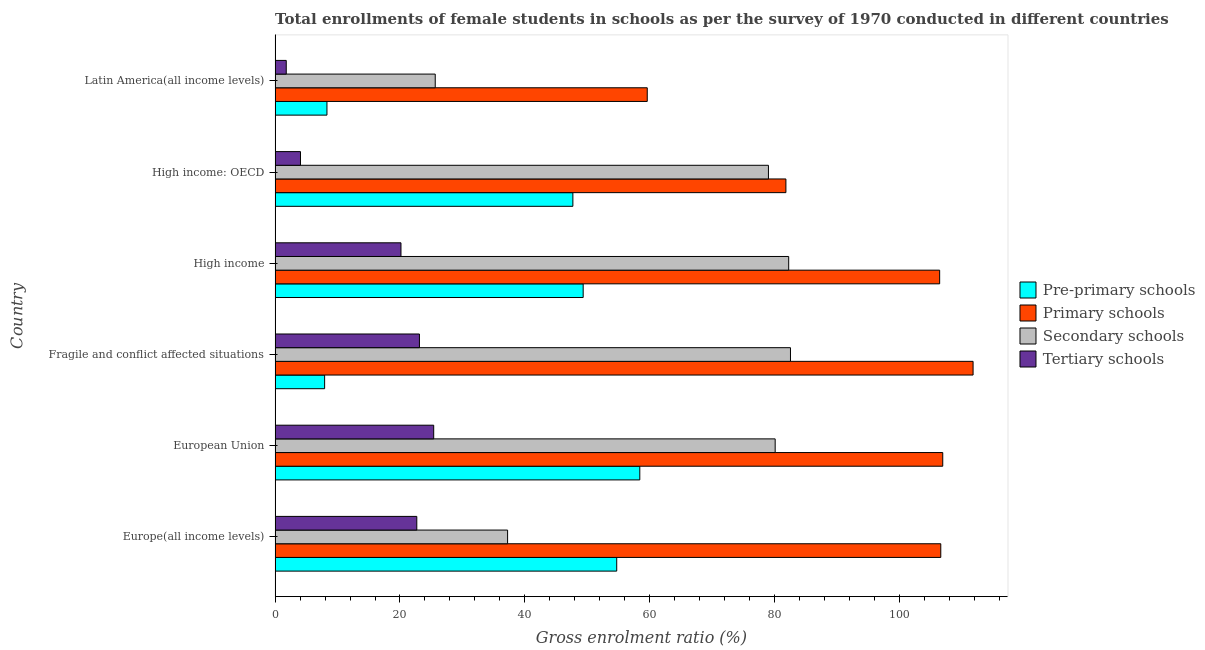How many different coloured bars are there?
Ensure brevity in your answer.  4. Are the number of bars on each tick of the Y-axis equal?
Give a very brief answer. Yes. How many bars are there on the 6th tick from the top?
Provide a short and direct response. 4. What is the label of the 6th group of bars from the top?
Provide a short and direct response. Europe(all income levels). What is the gross enrolment ratio(female) in pre-primary schools in Fragile and conflict affected situations?
Ensure brevity in your answer.  7.93. Across all countries, what is the maximum gross enrolment ratio(female) in pre-primary schools?
Provide a succinct answer. 58.41. Across all countries, what is the minimum gross enrolment ratio(female) in pre-primary schools?
Provide a short and direct response. 7.93. In which country was the gross enrolment ratio(female) in pre-primary schools maximum?
Your answer should be compact. European Union. In which country was the gross enrolment ratio(female) in secondary schools minimum?
Provide a succinct answer. Latin America(all income levels). What is the total gross enrolment ratio(female) in primary schools in the graph?
Your answer should be very brief. 573.13. What is the difference between the gross enrolment ratio(female) in pre-primary schools in European Union and that in High income?
Provide a short and direct response. 9.07. What is the difference between the gross enrolment ratio(female) in primary schools in Europe(all income levels) and the gross enrolment ratio(female) in pre-primary schools in European Union?
Give a very brief answer. 48.2. What is the average gross enrolment ratio(female) in pre-primary schools per country?
Ensure brevity in your answer.  37.73. What is the difference between the gross enrolment ratio(female) in secondary schools and gross enrolment ratio(female) in pre-primary schools in Latin America(all income levels)?
Keep it short and to the point. 17.34. What is the ratio of the gross enrolment ratio(female) in primary schools in European Union to that in Fragile and conflict affected situations?
Your answer should be compact. 0.96. What is the difference between the highest and the second highest gross enrolment ratio(female) in tertiary schools?
Provide a short and direct response. 2.29. What is the difference between the highest and the lowest gross enrolment ratio(female) in secondary schools?
Ensure brevity in your answer.  56.89. Is the sum of the gross enrolment ratio(female) in primary schools in Europe(all income levels) and Fragile and conflict affected situations greater than the maximum gross enrolment ratio(female) in pre-primary schools across all countries?
Give a very brief answer. Yes. What does the 4th bar from the top in European Union represents?
Offer a very short reply. Pre-primary schools. What does the 3rd bar from the bottom in High income represents?
Offer a very short reply. Secondary schools. Is it the case that in every country, the sum of the gross enrolment ratio(female) in pre-primary schools and gross enrolment ratio(female) in primary schools is greater than the gross enrolment ratio(female) in secondary schools?
Make the answer very short. Yes. How many bars are there?
Keep it short and to the point. 24. Are all the bars in the graph horizontal?
Offer a terse response. Yes. How many countries are there in the graph?
Keep it short and to the point. 6. Are the values on the major ticks of X-axis written in scientific E-notation?
Ensure brevity in your answer.  No. How many legend labels are there?
Keep it short and to the point. 4. What is the title of the graph?
Offer a very short reply. Total enrollments of female students in schools as per the survey of 1970 conducted in different countries. What is the Gross enrolment ratio (%) in Pre-primary schools in Europe(all income levels)?
Ensure brevity in your answer.  54.71. What is the Gross enrolment ratio (%) in Primary schools in Europe(all income levels)?
Your answer should be very brief. 106.6. What is the Gross enrolment ratio (%) of Secondary schools in Europe(all income levels)?
Provide a succinct answer. 37.23. What is the Gross enrolment ratio (%) in Tertiary schools in Europe(all income levels)?
Offer a very short reply. 22.69. What is the Gross enrolment ratio (%) in Pre-primary schools in European Union?
Your response must be concise. 58.41. What is the Gross enrolment ratio (%) of Primary schools in European Union?
Give a very brief answer. 106.92. What is the Gross enrolment ratio (%) of Secondary schools in European Union?
Offer a very short reply. 80.08. What is the Gross enrolment ratio (%) of Tertiary schools in European Union?
Your answer should be compact. 25.4. What is the Gross enrolment ratio (%) in Pre-primary schools in Fragile and conflict affected situations?
Provide a short and direct response. 7.93. What is the Gross enrolment ratio (%) of Primary schools in Fragile and conflict affected situations?
Provide a succinct answer. 111.78. What is the Gross enrolment ratio (%) of Secondary schools in Fragile and conflict affected situations?
Ensure brevity in your answer.  82.53. What is the Gross enrolment ratio (%) of Tertiary schools in Fragile and conflict affected situations?
Ensure brevity in your answer.  23.12. What is the Gross enrolment ratio (%) in Pre-primary schools in High income?
Make the answer very short. 49.34. What is the Gross enrolment ratio (%) of Primary schools in High income?
Your response must be concise. 106.42. What is the Gross enrolment ratio (%) of Secondary schools in High income?
Keep it short and to the point. 82.25. What is the Gross enrolment ratio (%) in Tertiary schools in High income?
Ensure brevity in your answer.  20.16. What is the Gross enrolment ratio (%) in Pre-primary schools in High income: OECD?
Make the answer very short. 47.69. What is the Gross enrolment ratio (%) in Primary schools in High income: OECD?
Make the answer very short. 81.8. What is the Gross enrolment ratio (%) of Secondary schools in High income: OECD?
Offer a terse response. 79.01. What is the Gross enrolment ratio (%) in Tertiary schools in High income: OECD?
Keep it short and to the point. 4.07. What is the Gross enrolment ratio (%) in Pre-primary schools in Latin America(all income levels)?
Make the answer very short. 8.31. What is the Gross enrolment ratio (%) in Primary schools in Latin America(all income levels)?
Offer a terse response. 59.6. What is the Gross enrolment ratio (%) of Secondary schools in Latin America(all income levels)?
Give a very brief answer. 25.65. What is the Gross enrolment ratio (%) in Tertiary schools in Latin America(all income levels)?
Make the answer very short. 1.79. Across all countries, what is the maximum Gross enrolment ratio (%) of Pre-primary schools?
Make the answer very short. 58.41. Across all countries, what is the maximum Gross enrolment ratio (%) of Primary schools?
Your response must be concise. 111.78. Across all countries, what is the maximum Gross enrolment ratio (%) of Secondary schools?
Offer a terse response. 82.53. Across all countries, what is the maximum Gross enrolment ratio (%) in Tertiary schools?
Give a very brief answer. 25.4. Across all countries, what is the minimum Gross enrolment ratio (%) of Pre-primary schools?
Keep it short and to the point. 7.93. Across all countries, what is the minimum Gross enrolment ratio (%) of Primary schools?
Provide a succinct answer. 59.6. Across all countries, what is the minimum Gross enrolment ratio (%) of Secondary schools?
Ensure brevity in your answer.  25.65. Across all countries, what is the minimum Gross enrolment ratio (%) in Tertiary schools?
Your answer should be very brief. 1.79. What is the total Gross enrolment ratio (%) in Pre-primary schools in the graph?
Make the answer very short. 226.38. What is the total Gross enrolment ratio (%) in Primary schools in the graph?
Your answer should be compact. 573.13. What is the total Gross enrolment ratio (%) of Secondary schools in the graph?
Provide a short and direct response. 386.75. What is the total Gross enrolment ratio (%) of Tertiary schools in the graph?
Your answer should be compact. 97.23. What is the difference between the Gross enrolment ratio (%) in Pre-primary schools in Europe(all income levels) and that in European Union?
Keep it short and to the point. -3.7. What is the difference between the Gross enrolment ratio (%) of Primary schools in Europe(all income levels) and that in European Union?
Your response must be concise. -0.31. What is the difference between the Gross enrolment ratio (%) of Secondary schools in Europe(all income levels) and that in European Union?
Your response must be concise. -42.85. What is the difference between the Gross enrolment ratio (%) in Tertiary schools in Europe(all income levels) and that in European Union?
Provide a succinct answer. -2.71. What is the difference between the Gross enrolment ratio (%) in Pre-primary schools in Europe(all income levels) and that in Fragile and conflict affected situations?
Your response must be concise. 46.78. What is the difference between the Gross enrolment ratio (%) of Primary schools in Europe(all income levels) and that in Fragile and conflict affected situations?
Make the answer very short. -5.17. What is the difference between the Gross enrolment ratio (%) of Secondary schools in Europe(all income levels) and that in Fragile and conflict affected situations?
Keep it short and to the point. -45.3. What is the difference between the Gross enrolment ratio (%) in Tertiary schools in Europe(all income levels) and that in Fragile and conflict affected situations?
Your answer should be very brief. -0.42. What is the difference between the Gross enrolment ratio (%) in Pre-primary schools in Europe(all income levels) and that in High income?
Your answer should be very brief. 5.37. What is the difference between the Gross enrolment ratio (%) in Primary schools in Europe(all income levels) and that in High income?
Keep it short and to the point. 0.18. What is the difference between the Gross enrolment ratio (%) of Secondary schools in Europe(all income levels) and that in High income?
Provide a short and direct response. -45.02. What is the difference between the Gross enrolment ratio (%) of Tertiary schools in Europe(all income levels) and that in High income?
Your answer should be very brief. 2.53. What is the difference between the Gross enrolment ratio (%) in Pre-primary schools in Europe(all income levels) and that in High income: OECD?
Keep it short and to the point. 7.02. What is the difference between the Gross enrolment ratio (%) in Primary schools in Europe(all income levels) and that in High income: OECD?
Provide a short and direct response. 24.8. What is the difference between the Gross enrolment ratio (%) in Secondary schools in Europe(all income levels) and that in High income: OECD?
Your answer should be compact. -41.77. What is the difference between the Gross enrolment ratio (%) in Tertiary schools in Europe(all income levels) and that in High income: OECD?
Offer a very short reply. 18.63. What is the difference between the Gross enrolment ratio (%) of Pre-primary schools in Europe(all income levels) and that in Latin America(all income levels)?
Keep it short and to the point. 46.4. What is the difference between the Gross enrolment ratio (%) in Primary schools in Europe(all income levels) and that in Latin America(all income levels)?
Your answer should be compact. 47.01. What is the difference between the Gross enrolment ratio (%) in Secondary schools in Europe(all income levels) and that in Latin America(all income levels)?
Keep it short and to the point. 11.59. What is the difference between the Gross enrolment ratio (%) in Tertiary schools in Europe(all income levels) and that in Latin America(all income levels)?
Your answer should be compact. 20.91. What is the difference between the Gross enrolment ratio (%) in Pre-primary schools in European Union and that in Fragile and conflict affected situations?
Offer a very short reply. 50.47. What is the difference between the Gross enrolment ratio (%) in Primary schools in European Union and that in Fragile and conflict affected situations?
Ensure brevity in your answer.  -4.86. What is the difference between the Gross enrolment ratio (%) in Secondary schools in European Union and that in Fragile and conflict affected situations?
Ensure brevity in your answer.  -2.45. What is the difference between the Gross enrolment ratio (%) of Tertiary schools in European Union and that in Fragile and conflict affected situations?
Your answer should be very brief. 2.28. What is the difference between the Gross enrolment ratio (%) in Pre-primary schools in European Union and that in High income?
Give a very brief answer. 9.07. What is the difference between the Gross enrolment ratio (%) in Primary schools in European Union and that in High income?
Give a very brief answer. 0.49. What is the difference between the Gross enrolment ratio (%) of Secondary schools in European Union and that in High income?
Offer a very short reply. -2.17. What is the difference between the Gross enrolment ratio (%) of Tertiary schools in European Union and that in High income?
Keep it short and to the point. 5.24. What is the difference between the Gross enrolment ratio (%) in Pre-primary schools in European Union and that in High income: OECD?
Give a very brief answer. 10.72. What is the difference between the Gross enrolment ratio (%) in Primary schools in European Union and that in High income: OECD?
Ensure brevity in your answer.  25.11. What is the difference between the Gross enrolment ratio (%) in Secondary schools in European Union and that in High income: OECD?
Your answer should be compact. 1.08. What is the difference between the Gross enrolment ratio (%) of Tertiary schools in European Union and that in High income: OECD?
Offer a very short reply. 21.33. What is the difference between the Gross enrolment ratio (%) in Pre-primary schools in European Union and that in Latin America(all income levels)?
Provide a succinct answer. 50.1. What is the difference between the Gross enrolment ratio (%) in Primary schools in European Union and that in Latin America(all income levels)?
Make the answer very short. 47.32. What is the difference between the Gross enrolment ratio (%) of Secondary schools in European Union and that in Latin America(all income levels)?
Provide a succinct answer. 54.44. What is the difference between the Gross enrolment ratio (%) of Tertiary schools in European Union and that in Latin America(all income levels)?
Keep it short and to the point. 23.61. What is the difference between the Gross enrolment ratio (%) of Pre-primary schools in Fragile and conflict affected situations and that in High income?
Make the answer very short. -41.4. What is the difference between the Gross enrolment ratio (%) in Primary schools in Fragile and conflict affected situations and that in High income?
Offer a very short reply. 5.35. What is the difference between the Gross enrolment ratio (%) in Secondary schools in Fragile and conflict affected situations and that in High income?
Offer a very short reply. 0.28. What is the difference between the Gross enrolment ratio (%) of Tertiary schools in Fragile and conflict affected situations and that in High income?
Make the answer very short. 2.96. What is the difference between the Gross enrolment ratio (%) of Pre-primary schools in Fragile and conflict affected situations and that in High income: OECD?
Your answer should be very brief. -39.76. What is the difference between the Gross enrolment ratio (%) of Primary schools in Fragile and conflict affected situations and that in High income: OECD?
Offer a very short reply. 29.97. What is the difference between the Gross enrolment ratio (%) in Secondary schools in Fragile and conflict affected situations and that in High income: OECD?
Keep it short and to the point. 3.53. What is the difference between the Gross enrolment ratio (%) in Tertiary schools in Fragile and conflict affected situations and that in High income: OECD?
Offer a terse response. 19.05. What is the difference between the Gross enrolment ratio (%) in Pre-primary schools in Fragile and conflict affected situations and that in Latin America(all income levels)?
Give a very brief answer. -0.37. What is the difference between the Gross enrolment ratio (%) of Primary schools in Fragile and conflict affected situations and that in Latin America(all income levels)?
Your response must be concise. 52.18. What is the difference between the Gross enrolment ratio (%) in Secondary schools in Fragile and conflict affected situations and that in Latin America(all income levels)?
Keep it short and to the point. 56.89. What is the difference between the Gross enrolment ratio (%) in Tertiary schools in Fragile and conflict affected situations and that in Latin America(all income levels)?
Provide a short and direct response. 21.33. What is the difference between the Gross enrolment ratio (%) of Pre-primary schools in High income and that in High income: OECD?
Provide a short and direct response. 1.65. What is the difference between the Gross enrolment ratio (%) in Primary schools in High income and that in High income: OECD?
Provide a succinct answer. 24.62. What is the difference between the Gross enrolment ratio (%) of Secondary schools in High income and that in High income: OECD?
Offer a terse response. 3.24. What is the difference between the Gross enrolment ratio (%) of Tertiary schools in High income and that in High income: OECD?
Your response must be concise. 16.09. What is the difference between the Gross enrolment ratio (%) in Pre-primary schools in High income and that in Latin America(all income levels)?
Offer a terse response. 41.03. What is the difference between the Gross enrolment ratio (%) in Primary schools in High income and that in Latin America(all income levels)?
Offer a terse response. 46.83. What is the difference between the Gross enrolment ratio (%) of Secondary schools in High income and that in Latin America(all income levels)?
Offer a terse response. 56.6. What is the difference between the Gross enrolment ratio (%) in Tertiary schools in High income and that in Latin America(all income levels)?
Ensure brevity in your answer.  18.37. What is the difference between the Gross enrolment ratio (%) in Pre-primary schools in High income: OECD and that in Latin America(all income levels)?
Your answer should be compact. 39.38. What is the difference between the Gross enrolment ratio (%) in Primary schools in High income: OECD and that in Latin America(all income levels)?
Your response must be concise. 22.21. What is the difference between the Gross enrolment ratio (%) in Secondary schools in High income: OECD and that in Latin America(all income levels)?
Make the answer very short. 53.36. What is the difference between the Gross enrolment ratio (%) in Tertiary schools in High income: OECD and that in Latin America(all income levels)?
Make the answer very short. 2.28. What is the difference between the Gross enrolment ratio (%) in Pre-primary schools in Europe(all income levels) and the Gross enrolment ratio (%) in Primary schools in European Union?
Your answer should be compact. -52.21. What is the difference between the Gross enrolment ratio (%) in Pre-primary schools in Europe(all income levels) and the Gross enrolment ratio (%) in Secondary schools in European Union?
Give a very brief answer. -25.37. What is the difference between the Gross enrolment ratio (%) of Pre-primary schools in Europe(all income levels) and the Gross enrolment ratio (%) of Tertiary schools in European Union?
Your answer should be compact. 29.31. What is the difference between the Gross enrolment ratio (%) of Primary schools in Europe(all income levels) and the Gross enrolment ratio (%) of Secondary schools in European Union?
Ensure brevity in your answer.  26.52. What is the difference between the Gross enrolment ratio (%) of Primary schools in Europe(all income levels) and the Gross enrolment ratio (%) of Tertiary schools in European Union?
Your answer should be very brief. 81.2. What is the difference between the Gross enrolment ratio (%) in Secondary schools in Europe(all income levels) and the Gross enrolment ratio (%) in Tertiary schools in European Union?
Give a very brief answer. 11.83. What is the difference between the Gross enrolment ratio (%) in Pre-primary schools in Europe(all income levels) and the Gross enrolment ratio (%) in Primary schools in Fragile and conflict affected situations?
Offer a very short reply. -57.07. What is the difference between the Gross enrolment ratio (%) in Pre-primary schools in Europe(all income levels) and the Gross enrolment ratio (%) in Secondary schools in Fragile and conflict affected situations?
Offer a very short reply. -27.82. What is the difference between the Gross enrolment ratio (%) in Pre-primary schools in Europe(all income levels) and the Gross enrolment ratio (%) in Tertiary schools in Fragile and conflict affected situations?
Ensure brevity in your answer.  31.59. What is the difference between the Gross enrolment ratio (%) in Primary schools in Europe(all income levels) and the Gross enrolment ratio (%) in Secondary schools in Fragile and conflict affected situations?
Offer a very short reply. 24.07. What is the difference between the Gross enrolment ratio (%) of Primary schools in Europe(all income levels) and the Gross enrolment ratio (%) of Tertiary schools in Fragile and conflict affected situations?
Make the answer very short. 83.49. What is the difference between the Gross enrolment ratio (%) in Secondary schools in Europe(all income levels) and the Gross enrolment ratio (%) in Tertiary schools in Fragile and conflict affected situations?
Give a very brief answer. 14.12. What is the difference between the Gross enrolment ratio (%) in Pre-primary schools in Europe(all income levels) and the Gross enrolment ratio (%) in Primary schools in High income?
Make the answer very short. -51.71. What is the difference between the Gross enrolment ratio (%) of Pre-primary schools in Europe(all income levels) and the Gross enrolment ratio (%) of Secondary schools in High income?
Your response must be concise. -27.54. What is the difference between the Gross enrolment ratio (%) of Pre-primary schools in Europe(all income levels) and the Gross enrolment ratio (%) of Tertiary schools in High income?
Your response must be concise. 34.55. What is the difference between the Gross enrolment ratio (%) of Primary schools in Europe(all income levels) and the Gross enrolment ratio (%) of Secondary schools in High income?
Offer a terse response. 24.36. What is the difference between the Gross enrolment ratio (%) in Primary schools in Europe(all income levels) and the Gross enrolment ratio (%) in Tertiary schools in High income?
Make the answer very short. 86.44. What is the difference between the Gross enrolment ratio (%) of Secondary schools in Europe(all income levels) and the Gross enrolment ratio (%) of Tertiary schools in High income?
Offer a very short reply. 17.07. What is the difference between the Gross enrolment ratio (%) in Pre-primary schools in Europe(all income levels) and the Gross enrolment ratio (%) in Primary schools in High income: OECD?
Ensure brevity in your answer.  -27.09. What is the difference between the Gross enrolment ratio (%) of Pre-primary schools in Europe(all income levels) and the Gross enrolment ratio (%) of Secondary schools in High income: OECD?
Provide a succinct answer. -24.3. What is the difference between the Gross enrolment ratio (%) in Pre-primary schools in Europe(all income levels) and the Gross enrolment ratio (%) in Tertiary schools in High income: OECD?
Offer a very short reply. 50.64. What is the difference between the Gross enrolment ratio (%) of Primary schools in Europe(all income levels) and the Gross enrolment ratio (%) of Secondary schools in High income: OECD?
Provide a succinct answer. 27.6. What is the difference between the Gross enrolment ratio (%) in Primary schools in Europe(all income levels) and the Gross enrolment ratio (%) in Tertiary schools in High income: OECD?
Offer a terse response. 102.54. What is the difference between the Gross enrolment ratio (%) in Secondary schools in Europe(all income levels) and the Gross enrolment ratio (%) in Tertiary schools in High income: OECD?
Offer a very short reply. 33.17. What is the difference between the Gross enrolment ratio (%) of Pre-primary schools in Europe(all income levels) and the Gross enrolment ratio (%) of Primary schools in Latin America(all income levels)?
Offer a terse response. -4.89. What is the difference between the Gross enrolment ratio (%) of Pre-primary schools in Europe(all income levels) and the Gross enrolment ratio (%) of Secondary schools in Latin America(all income levels)?
Your answer should be compact. 29.06. What is the difference between the Gross enrolment ratio (%) in Pre-primary schools in Europe(all income levels) and the Gross enrolment ratio (%) in Tertiary schools in Latin America(all income levels)?
Ensure brevity in your answer.  52.92. What is the difference between the Gross enrolment ratio (%) in Primary schools in Europe(all income levels) and the Gross enrolment ratio (%) in Secondary schools in Latin America(all income levels)?
Provide a short and direct response. 80.96. What is the difference between the Gross enrolment ratio (%) in Primary schools in Europe(all income levels) and the Gross enrolment ratio (%) in Tertiary schools in Latin America(all income levels)?
Offer a terse response. 104.82. What is the difference between the Gross enrolment ratio (%) of Secondary schools in Europe(all income levels) and the Gross enrolment ratio (%) of Tertiary schools in Latin America(all income levels)?
Give a very brief answer. 35.45. What is the difference between the Gross enrolment ratio (%) of Pre-primary schools in European Union and the Gross enrolment ratio (%) of Primary schools in Fragile and conflict affected situations?
Keep it short and to the point. -53.37. What is the difference between the Gross enrolment ratio (%) of Pre-primary schools in European Union and the Gross enrolment ratio (%) of Secondary schools in Fragile and conflict affected situations?
Your answer should be very brief. -24.13. What is the difference between the Gross enrolment ratio (%) in Pre-primary schools in European Union and the Gross enrolment ratio (%) in Tertiary schools in Fragile and conflict affected situations?
Offer a very short reply. 35.29. What is the difference between the Gross enrolment ratio (%) of Primary schools in European Union and the Gross enrolment ratio (%) of Secondary schools in Fragile and conflict affected situations?
Give a very brief answer. 24.39. What is the difference between the Gross enrolment ratio (%) in Primary schools in European Union and the Gross enrolment ratio (%) in Tertiary schools in Fragile and conflict affected situations?
Your answer should be compact. 83.8. What is the difference between the Gross enrolment ratio (%) of Secondary schools in European Union and the Gross enrolment ratio (%) of Tertiary schools in Fragile and conflict affected situations?
Offer a terse response. 56.97. What is the difference between the Gross enrolment ratio (%) in Pre-primary schools in European Union and the Gross enrolment ratio (%) in Primary schools in High income?
Make the answer very short. -48.02. What is the difference between the Gross enrolment ratio (%) in Pre-primary schools in European Union and the Gross enrolment ratio (%) in Secondary schools in High income?
Keep it short and to the point. -23.84. What is the difference between the Gross enrolment ratio (%) of Pre-primary schools in European Union and the Gross enrolment ratio (%) of Tertiary schools in High income?
Keep it short and to the point. 38.24. What is the difference between the Gross enrolment ratio (%) in Primary schools in European Union and the Gross enrolment ratio (%) in Secondary schools in High income?
Your answer should be very brief. 24.67. What is the difference between the Gross enrolment ratio (%) of Primary schools in European Union and the Gross enrolment ratio (%) of Tertiary schools in High income?
Ensure brevity in your answer.  86.76. What is the difference between the Gross enrolment ratio (%) in Secondary schools in European Union and the Gross enrolment ratio (%) in Tertiary schools in High income?
Provide a short and direct response. 59.92. What is the difference between the Gross enrolment ratio (%) of Pre-primary schools in European Union and the Gross enrolment ratio (%) of Primary schools in High income: OECD?
Your response must be concise. -23.4. What is the difference between the Gross enrolment ratio (%) of Pre-primary schools in European Union and the Gross enrolment ratio (%) of Secondary schools in High income: OECD?
Provide a short and direct response. -20.6. What is the difference between the Gross enrolment ratio (%) of Pre-primary schools in European Union and the Gross enrolment ratio (%) of Tertiary schools in High income: OECD?
Provide a succinct answer. 54.34. What is the difference between the Gross enrolment ratio (%) of Primary schools in European Union and the Gross enrolment ratio (%) of Secondary schools in High income: OECD?
Offer a terse response. 27.91. What is the difference between the Gross enrolment ratio (%) of Primary schools in European Union and the Gross enrolment ratio (%) of Tertiary schools in High income: OECD?
Offer a terse response. 102.85. What is the difference between the Gross enrolment ratio (%) in Secondary schools in European Union and the Gross enrolment ratio (%) in Tertiary schools in High income: OECD?
Keep it short and to the point. 76.02. What is the difference between the Gross enrolment ratio (%) in Pre-primary schools in European Union and the Gross enrolment ratio (%) in Primary schools in Latin America(all income levels)?
Your response must be concise. -1.19. What is the difference between the Gross enrolment ratio (%) of Pre-primary schools in European Union and the Gross enrolment ratio (%) of Secondary schools in Latin America(all income levels)?
Ensure brevity in your answer.  32.76. What is the difference between the Gross enrolment ratio (%) in Pre-primary schools in European Union and the Gross enrolment ratio (%) in Tertiary schools in Latin America(all income levels)?
Keep it short and to the point. 56.62. What is the difference between the Gross enrolment ratio (%) of Primary schools in European Union and the Gross enrolment ratio (%) of Secondary schools in Latin America(all income levels)?
Your answer should be very brief. 81.27. What is the difference between the Gross enrolment ratio (%) of Primary schools in European Union and the Gross enrolment ratio (%) of Tertiary schools in Latin America(all income levels)?
Provide a succinct answer. 105.13. What is the difference between the Gross enrolment ratio (%) of Secondary schools in European Union and the Gross enrolment ratio (%) of Tertiary schools in Latin America(all income levels)?
Your answer should be very brief. 78.3. What is the difference between the Gross enrolment ratio (%) of Pre-primary schools in Fragile and conflict affected situations and the Gross enrolment ratio (%) of Primary schools in High income?
Provide a short and direct response. -98.49. What is the difference between the Gross enrolment ratio (%) in Pre-primary schools in Fragile and conflict affected situations and the Gross enrolment ratio (%) in Secondary schools in High income?
Offer a very short reply. -74.32. What is the difference between the Gross enrolment ratio (%) of Pre-primary schools in Fragile and conflict affected situations and the Gross enrolment ratio (%) of Tertiary schools in High income?
Provide a short and direct response. -12.23. What is the difference between the Gross enrolment ratio (%) of Primary schools in Fragile and conflict affected situations and the Gross enrolment ratio (%) of Secondary schools in High income?
Offer a very short reply. 29.53. What is the difference between the Gross enrolment ratio (%) of Primary schools in Fragile and conflict affected situations and the Gross enrolment ratio (%) of Tertiary schools in High income?
Your response must be concise. 91.62. What is the difference between the Gross enrolment ratio (%) of Secondary schools in Fragile and conflict affected situations and the Gross enrolment ratio (%) of Tertiary schools in High income?
Make the answer very short. 62.37. What is the difference between the Gross enrolment ratio (%) in Pre-primary schools in Fragile and conflict affected situations and the Gross enrolment ratio (%) in Primary schools in High income: OECD?
Provide a short and direct response. -73.87. What is the difference between the Gross enrolment ratio (%) of Pre-primary schools in Fragile and conflict affected situations and the Gross enrolment ratio (%) of Secondary schools in High income: OECD?
Your answer should be very brief. -71.07. What is the difference between the Gross enrolment ratio (%) in Pre-primary schools in Fragile and conflict affected situations and the Gross enrolment ratio (%) in Tertiary schools in High income: OECD?
Make the answer very short. 3.87. What is the difference between the Gross enrolment ratio (%) in Primary schools in Fragile and conflict affected situations and the Gross enrolment ratio (%) in Secondary schools in High income: OECD?
Give a very brief answer. 32.77. What is the difference between the Gross enrolment ratio (%) in Primary schools in Fragile and conflict affected situations and the Gross enrolment ratio (%) in Tertiary schools in High income: OECD?
Offer a terse response. 107.71. What is the difference between the Gross enrolment ratio (%) in Secondary schools in Fragile and conflict affected situations and the Gross enrolment ratio (%) in Tertiary schools in High income: OECD?
Offer a terse response. 78.47. What is the difference between the Gross enrolment ratio (%) in Pre-primary schools in Fragile and conflict affected situations and the Gross enrolment ratio (%) in Primary schools in Latin America(all income levels)?
Provide a succinct answer. -51.67. What is the difference between the Gross enrolment ratio (%) in Pre-primary schools in Fragile and conflict affected situations and the Gross enrolment ratio (%) in Secondary schools in Latin America(all income levels)?
Keep it short and to the point. -17.71. What is the difference between the Gross enrolment ratio (%) of Pre-primary schools in Fragile and conflict affected situations and the Gross enrolment ratio (%) of Tertiary schools in Latin America(all income levels)?
Your answer should be compact. 6.15. What is the difference between the Gross enrolment ratio (%) in Primary schools in Fragile and conflict affected situations and the Gross enrolment ratio (%) in Secondary schools in Latin America(all income levels)?
Your answer should be compact. 86.13. What is the difference between the Gross enrolment ratio (%) of Primary schools in Fragile and conflict affected situations and the Gross enrolment ratio (%) of Tertiary schools in Latin America(all income levels)?
Provide a short and direct response. 109.99. What is the difference between the Gross enrolment ratio (%) of Secondary schools in Fragile and conflict affected situations and the Gross enrolment ratio (%) of Tertiary schools in Latin America(all income levels)?
Ensure brevity in your answer.  80.75. What is the difference between the Gross enrolment ratio (%) in Pre-primary schools in High income and the Gross enrolment ratio (%) in Primary schools in High income: OECD?
Keep it short and to the point. -32.47. What is the difference between the Gross enrolment ratio (%) of Pre-primary schools in High income and the Gross enrolment ratio (%) of Secondary schools in High income: OECD?
Ensure brevity in your answer.  -29.67. What is the difference between the Gross enrolment ratio (%) in Pre-primary schools in High income and the Gross enrolment ratio (%) in Tertiary schools in High income: OECD?
Your response must be concise. 45.27. What is the difference between the Gross enrolment ratio (%) of Primary schools in High income and the Gross enrolment ratio (%) of Secondary schools in High income: OECD?
Offer a terse response. 27.42. What is the difference between the Gross enrolment ratio (%) of Primary schools in High income and the Gross enrolment ratio (%) of Tertiary schools in High income: OECD?
Keep it short and to the point. 102.36. What is the difference between the Gross enrolment ratio (%) of Secondary schools in High income and the Gross enrolment ratio (%) of Tertiary schools in High income: OECD?
Your answer should be compact. 78.18. What is the difference between the Gross enrolment ratio (%) of Pre-primary schools in High income and the Gross enrolment ratio (%) of Primary schools in Latin America(all income levels)?
Offer a very short reply. -10.26. What is the difference between the Gross enrolment ratio (%) of Pre-primary schools in High income and the Gross enrolment ratio (%) of Secondary schools in Latin America(all income levels)?
Offer a very short reply. 23.69. What is the difference between the Gross enrolment ratio (%) in Pre-primary schools in High income and the Gross enrolment ratio (%) in Tertiary schools in Latin America(all income levels)?
Your answer should be very brief. 47.55. What is the difference between the Gross enrolment ratio (%) of Primary schools in High income and the Gross enrolment ratio (%) of Secondary schools in Latin America(all income levels)?
Keep it short and to the point. 80.78. What is the difference between the Gross enrolment ratio (%) of Primary schools in High income and the Gross enrolment ratio (%) of Tertiary schools in Latin America(all income levels)?
Offer a terse response. 104.64. What is the difference between the Gross enrolment ratio (%) of Secondary schools in High income and the Gross enrolment ratio (%) of Tertiary schools in Latin America(all income levels)?
Give a very brief answer. 80.46. What is the difference between the Gross enrolment ratio (%) in Pre-primary schools in High income: OECD and the Gross enrolment ratio (%) in Primary schools in Latin America(all income levels)?
Provide a short and direct response. -11.91. What is the difference between the Gross enrolment ratio (%) of Pre-primary schools in High income: OECD and the Gross enrolment ratio (%) of Secondary schools in Latin America(all income levels)?
Ensure brevity in your answer.  22.04. What is the difference between the Gross enrolment ratio (%) in Pre-primary schools in High income: OECD and the Gross enrolment ratio (%) in Tertiary schools in Latin America(all income levels)?
Ensure brevity in your answer.  45.9. What is the difference between the Gross enrolment ratio (%) in Primary schools in High income: OECD and the Gross enrolment ratio (%) in Secondary schools in Latin America(all income levels)?
Ensure brevity in your answer.  56.16. What is the difference between the Gross enrolment ratio (%) in Primary schools in High income: OECD and the Gross enrolment ratio (%) in Tertiary schools in Latin America(all income levels)?
Keep it short and to the point. 80.02. What is the difference between the Gross enrolment ratio (%) in Secondary schools in High income: OECD and the Gross enrolment ratio (%) in Tertiary schools in Latin America(all income levels)?
Keep it short and to the point. 77.22. What is the average Gross enrolment ratio (%) of Pre-primary schools per country?
Offer a terse response. 37.73. What is the average Gross enrolment ratio (%) of Primary schools per country?
Your response must be concise. 95.52. What is the average Gross enrolment ratio (%) in Secondary schools per country?
Offer a terse response. 64.46. What is the average Gross enrolment ratio (%) in Tertiary schools per country?
Your answer should be compact. 16.2. What is the difference between the Gross enrolment ratio (%) in Pre-primary schools and Gross enrolment ratio (%) in Primary schools in Europe(all income levels)?
Keep it short and to the point. -51.89. What is the difference between the Gross enrolment ratio (%) of Pre-primary schools and Gross enrolment ratio (%) of Secondary schools in Europe(all income levels)?
Your answer should be very brief. 17.48. What is the difference between the Gross enrolment ratio (%) in Pre-primary schools and Gross enrolment ratio (%) in Tertiary schools in Europe(all income levels)?
Offer a very short reply. 32.02. What is the difference between the Gross enrolment ratio (%) of Primary schools and Gross enrolment ratio (%) of Secondary schools in Europe(all income levels)?
Provide a short and direct response. 69.37. What is the difference between the Gross enrolment ratio (%) in Primary schools and Gross enrolment ratio (%) in Tertiary schools in Europe(all income levels)?
Keep it short and to the point. 83.91. What is the difference between the Gross enrolment ratio (%) of Secondary schools and Gross enrolment ratio (%) of Tertiary schools in Europe(all income levels)?
Your answer should be very brief. 14.54. What is the difference between the Gross enrolment ratio (%) in Pre-primary schools and Gross enrolment ratio (%) in Primary schools in European Union?
Make the answer very short. -48.51. What is the difference between the Gross enrolment ratio (%) of Pre-primary schools and Gross enrolment ratio (%) of Secondary schools in European Union?
Ensure brevity in your answer.  -21.68. What is the difference between the Gross enrolment ratio (%) in Pre-primary schools and Gross enrolment ratio (%) in Tertiary schools in European Union?
Your response must be concise. 33. What is the difference between the Gross enrolment ratio (%) in Primary schools and Gross enrolment ratio (%) in Secondary schools in European Union?
Your response must be concise. 26.84. What is the difference between the Gross enrolment ratio (%) of Primary schools and Gross enrolment ratio (%) of Tertiary schools in European Union?
Ensure brevity in your answer.  81.52. What is the difference between the Gross enrolment ratio (%) in Secondary schools and Gross enrolment ratio (%) in Tertiary schools in European Union?
Your answer should be compact. 54.68. What is the difference between the Gross enrolment ratio (%) in Pre-primary schools and Gross enrolment ratio (%) in Primary schools in Fragile and conflict affected situations?
Provide a succinct answer. -103.84. What is the difference between the Gross enrolment ratio (%) of Pre-primary schools and Gross enrolment ratio (%) of Secondary schools in Fragile and conflict affected situations?
Make the answer very short. -74.6. What is the difference between the Gross enrolment ratio (%) of Pre-primary schools and Gross enrolment ratio (%) of Tertiary schools in Fragile and conflict affected situations?
Keep it short and to the point. -15.18. What is the difference between the Gross enrolment ratio (%) in Primary schools and Gross enrolment ratio (%) in Secondary schools in Fragile and conflict affected situations?
Offer a very short reply. 29.24. What is the difference between the Gross enrolment ratio (%) in Primary schools and Gross enrolment ratio (%) in Tertiary schools in Fragile and conflict affected situations?
Your answer should be compact. 88.66. What is the difference between the Gross enrolment ratio (%) of Secondary schools and Gross enrolment ratio (%) of Tertiary schools in Fragile and conflict affected situations?
Your answer should be very brief. 59.42. What is the difference between the Gross enrolment ratio (%) of Pre-primary schools and Gross enrolment ratio (%) of Primary schools in High income?
Give a very brief answer. -57.09. What is the difference between the Gross enrolment ratio (%) of Pre-primary schools and Gross enrolment ratio (%) of Secondary schools in High income?
Offer a terse response. -32.91. What is the difference between the Gross enrolment ratio (%) of Pre-primary schools and Gross enrolment ratio (%) of Tertiary schools in High income?
Keep it short and to the point. 29.18. What is the difference between the Gross enrolment ratio (%) of Primary schools and Gross enrolment ratio (%) of Secondary schools in High income?
Your response must be concise. 24.18. What is the difference between the Gross enrolment ratio (%) of Primary schools and Gross enrolment ratio (%) of Tertiary schools in High income?
Provide a short and direct response. 86.26. What is the difference between the Gross enrolment ratio (%) of Secondary schools and Gross enrolment ratio (%) of Tertiary schools in High income?
Offer a very short reply. 62.09. What is the difference between the Gross enrolment ratio (%) of Pre-primary schools and Gross enrolment ratio (%) of Primary schools in High income: OECD?
Keep it short and to the point. -34.12. What is the difference between the Gross enrolment ratio (%) in Pre-primary schools and Gross enrolment ratio (%) in Secondary schools in High income: OECD?
Provide a succinct answer. -31.32. What is the difference between the Gross enrolment ratio (%) of Pre-primary schools and Gross enrolment ratio (%) of Tertiary schools in High income: OECD?
Offer a very short reply. 43.62. What is the difference between the Gross enrolment ratio (%) in Primary schools and Gross enrolment ratio (%) in Secondary schools in High income: OECD?
Make the answer very short. 2.8. What is the difference between the Gross enrolment ratio (%) of Primary schools and Gross enrolment ratio (%) of Tertiary schools in High income: OECD?
Your answer should be compact. 77.74. What is the difference between the Gross enrolment ratio (%) of Secondary schools and Gross enrolment ratio (%) of Tertiary schools in High income: OECD?
Your response must be concise. 74.94. What is the difference between the Gross enrolment ratio (%) in Pre-primary schools and Gross enrolment ratio (%) in Primary schools in Latin America(all income levels)?
Your response must be concise. -51.29. What is the difference between the Gross enrolment ratio (%) of Pre-primary schools and Gross enrolment ratio (%) of Secondary schools in Latin America(all income levels)?
Your response must be concise. -17.34. What is the difference between the Gross enrolment ratio (%) of Pre-primary schools and Gross enrolment ratio (%) of Tertiary schools in Latin America(all income levels)?
Your answer should be compact. 6.52. What is the difference between the Gross enrolment ratio (%) in Primary schools and Gross enrolment ratio (%) in Secondary schools in Latin America(all income levels)?
Provide a short and direct response. 33.95. What is the difference between the Gross enrolment ratio (%) in Primary schools and Gross enrolment ratio (%) in Tertiary schools in Latin America(all income levels)?
Your response must be concise. 57.81. What is the difference between the Gross enrolment ratio (%) of Secondary schools and Gross enrolment ratio (%) of Tertiary schools in Latin America(all income levels)?
Ensure brevity in your answer.  23.86. What is the ratio of the Gross enrolment ratio (%) in Pre-primary schools in Europe(all income levels) to that in European Union?
Give a very brief answer. 0.94. What is the ratio of the Gross enrolment ratio (%) of Primary schools in Europe(all income levels) to that in European Union?
Offer a terse response. 1. What is the ratio of the Gross enrolment ratio (%) in Secondary schools in Europe(all income levels) to that in European Union?
Provide a short and direct response. 0.46. What is the ratio of the Gross enrolment ratio (%) of Tertiary schools in Europe(all income levels) to that in European Union?
Your response must be concise. 0.89. What is the ratio of the Gross enrolment ratio (%) of Pre-primary schools in Europe(all income levels) to that in Fragile and conflict affected situations?
Give a very brief answer. 6.9. What is the ratio of the Gross enrolment ratio (%) of Primary schools in Europe(all income levels) to that in Fragile and conflict affected situations?
Give a very brief answer. 0.95. What is the ratio of the Gross enrolment ratio (%) of Secondary schools in Europe(all income levels) to that in Fragile and conflict affected situations?
Provide a short and direct response. 0.45. What is the ratio of the Gross enrolment ratio (%) in Tertiary schools in Europe(all income levels) to that in Fragile and conflict affected situations?
Make the answer very short. 0.98. What is the ratio of the Gross enrolment ratio (%) in Pre-primary schools in Europe(all income levels) to that in High income?
Ensure brevity in your answer.  1.11. What is the ratio of the Gross enrolment ratio (%) in Secondary schools in Europe(all income levels) to that in High income?
Your answer should be compact. 0.45. What is the ratio of the Gross enrolment ratio (%) of Tertiary schools in Europe(all income levels) to that in High income?
Ensure brevity in your answer.  1.13. What is the ratio of the Gross enrolment ratio (%) in Pre-primary schools in Europe(all income levels) to that in High income: OECD?
Provide a short and direct response. 1.15. What is the ratio of the Gross enrolment ratio (%) in Primary schools in Europe(all income levels) to that in High income: OECD?
Your answer should be compact. 1.3. What is the ratio of the Gross enrolment ratio (%) in Secondary schools in Europe(all income levels) to that in High income: OECD?
Your answer should be compact. 0.47. What is the ratio of the Gross enrolment ratio (%) in Tertiary schools in Europe(all income levels) to that in High income: OECD?
Provide a short and direct response. 5.58. What is the ratio of the Gross enrolment ratio (%) of Pre-primary schools in Europe(all income levels) to that in Latin America(all income levels)?
Your answer should be compact. 6.59. What is the ratio of the Gross enrolment ratio (%) of Primary schools in Europe(all income levels) to that in Latin America(all income levels)?
Offer a terse response. 1.79. What is the ratio of the Gross enrolment ratio (%) of Secondary schools in Europe(all income levels) to that in Latin America(all income levels)?
Your response must be concise. 1.45. What is the ratio of the Gross enrolment ratio (%) in Tertiary schools in Europe(all income levels) to that in Latin America(all income levels)?
Offer a terse response. 12.69. What is the ratio of the Gross enrolment ratio (%) of Pre-primary schools in European Union to that in Fragile and conflict affected situations?
Provide a short and direct response. 7.36. What is the ratio of the Gross enrolment ratio (%) of Primary schools in European Union to that in Fragile and conflict affected situations?
Ensure brevity in your answer.  0.96. What is the ratio of the Gross enrolment ratio (%) in Secondary schools in European Union to that in Fragile and conflict affected situations?
Your answer should be very brief. 0.97. What is the ratio of the Gross enrolment ratio (%) of Tertiary schools in European Union to that in Fragile and conflict affected situations?
Your answer should be compact. 1.1. What is the ratio of the Gross enrolment ratio (%) in Pre-primary schools in European Union to that in High income?
Ensure brevity in your answer.  1.18. What is the ratio of the Gross enrolment ratio (%) of Secondary schools in European Union to that in High income?
Provide a short and direct response. 0.97. What is the ratio of the Gross enrolment ratio (%) of Tertiary schools in European Union to that in High income?
Offer a terse response. 1.26. What is the ratio of the Gross enrolment ratio (%) of Pre-primary schools in European Union to that in High income: OECD?
Give a very brief answer. 1.22. What is the ratio of the Gross enrolment ratio (%) in Primary schools in European Union to that in High income: OECD?
Your answer should be very brief. 1.31. What is the ratio of the Gross enrolment ratio (%) of Secondary schools in European Union to that in High income: OECD?
Give a very brief answer. 1.01. What is the ratio of the Gross enrolment ratio (%) in Tertiary schools in European Union to that in High income: OECD?
Provide a short and direct response. 6.24. What is the ratio of the Gross enrolment ratio (%) of Pre-primary schools in European Union to that in Latin America(all income levels)?
Ensure brevity in your answer.  7.03. What is the ratio of the Gross enrolment ratio (%) in Primary schools in European Union to that in Latin America(all income levels)?
Your answer should be very brief. 1.79. What is the ratio of the Gross enrolment ratio (%) in Secondary schools in European Union to that in Latin America(all income levels)?
Provide a short and direct response. 3.12. What is the ratio of the Gross enrolment ratio (%) of Tertiary schools in European Union to that in Latin America(all income levels)?
Ensure brevity in your answer.  14.2. What is the ratio of the Gross enrolment ratio (%) of Pre-primary schools in Fragile and conflict affected situations to that in High income?
Offer a very short reply. 0.16. What is the ratio of the Gross enrolment ratio (%) in Primary schools in Fragile and conflict affected situations to that in High income?
Provide a succinct answer. 1.05. What is the ratio of the Gross enrolment ratio (%) of Secondary schools in Fragile and conflict affected situations to that in High income?
Your answer should be very brief. 1. What is the ratio of the Gross enrolment ratio (%) in Tertiary schools in Fragile and conflict affected situations to that in High income?
Make the answer very short. 1.15. What is the ratio of the Gross enrolment ratio (%) in Pre-primary schools in Fragile and conflict affected situations to that in High income: OECD?
Offer a very short reply. 0.17. What is the ratio of the Gross enrolment ratio (%) of Primary schools in Fragile and conflict affected situations to that in High income: OECD?
Keep it short and to the point. 1.37. What is the ratio of the Gross enrolment ratio (%) in Secondary schools in Fragile and conflict affected situations to that in High income: OECD?
Give a very brief answer. 1.04. What is the ratio of the Gross enrolment ratio (%) in Tertiary schools in Fragile and conflict affected situations to that in High income: OECD?
Provide a short and direct response. 5.68. What is the ratio of the Gross enrolment ratio (%) in Pre-primary schools in Fragile and conflict affected situations to that in Latin America(all income levels)?
Provide a succinct answer. 0.96. What is the ratio of the Gross enrolment ratio (%) of Primary schools in Fragile and conflict affected situations to that in Latin America(all income levels)?
Offer a very short reply. 1.88. What is the ratio of the Gross enrolment ratio (%) of Secondary schools in Fragile and conflict affected situations to that in Latin America(all income levels)?
Give a very brief answer. 3.22. What is the ratio of the Gross enrolment ratio (%) of Tertiary schools in Fragile and conflict affected situations to that in Latin America(all income levels)?
Keep it short and to the point. 12.93. What is the ratio of the Gross enrolment ratio (%) in Pre-primary schools in High income to that in High income: OECD?
Your response must be concise. 1.03. What is the ratio of the Gross enrolment ratio (%) in Primary schools in High income to that in High income: OECD?
Provide a short and direct response. 1.3. What is the ratio of the Gross enrolment ratio (%) of Secondary schools in High income to that in High income: OECD?
Provide a succinct answer. 1.04. What is the ratio of the Gross enrolment ratio (%) in Tertiary schools in High income to that in High income: OECD?
Ensure brevity in your answer.  4.96. What is the ratio of the Gross enrolment ratio (%) in Pre-primary schools in High income to that in Latin America(all income levels)?
Ensure brevity in your answer.  5.94. What is the ratio of the Gross enrolment ratio (%) of Primary schools in High income to that in Latin America(all income levels)?
Your response must be concise. 1.79. What is the ratio of the Gross enrolment ratio (%) of Secondary schools in High income to that in Latin America(all income levels)?
Offer a very short reply. 3.21. What is the ratio of the Gross enrolment ratio (%) in Tertiary schools in High income to that in Latin America(all income levels)?
Your answer should be very brief. 11.27. What is the ratio of the Gross enrolment ratio (%) in Pre-primary schools in High income: OECD to that in Latin America(all income levels)?
Ensure brevity in your answer.  5.74. What is the ratio of the Gross enrolment ratio (%) of Primary schools in High income: OECD to that in Latin America(all income levels)?
Your answer should be very brief. 1.37. What is the ratio of the Gross enrolment ratio (%) in Secondary schools in High income: OECD to that in Latin America(all income levels)?
Provide a short and direct response. 3.08. What is the ratio of the Gross enrolment ratio (%) of Tertiary schools in High income: OECD to that in Latin America(all income levels)?
Keep it short and to the point. 2.27. What is the difference between the highest and the second highest Gross enrolment ratio (%) of Pre-primary schools?
Give a very brief answer. 3.7. What is the difference between the highest and the second highest Gross enrolment ratio (%) of Primary schools?
Make the answer very short. 4.86. What is the difference between the highest and the second highest Gross enrolment ratio (%) in Secondary schools?
Offer a terse response. 0.28. What is the difference between the highest and the second highest Gross enrolment ratio (%) of Tertiary schools?
Give a very brief answer. 2.28. What is the difference between the highest and the lowest Gross enrolment ratio (%) in Pre-primary schools?
Your response must be concise. 50.47. What is the difference between the highest and the lowest Gross enrolment ratio (%) of Primary schools?
Offer a terse response. 52.18. What is the difference between the highest and the lowest Gross enrolment ratio (%) in Secondary schools?
Your response must be concise. 56.89. What is the difference between the highest and the lowest Gross enrolment ratio (%) in Tertiary schools?
Offer a terse response. 23.61. 